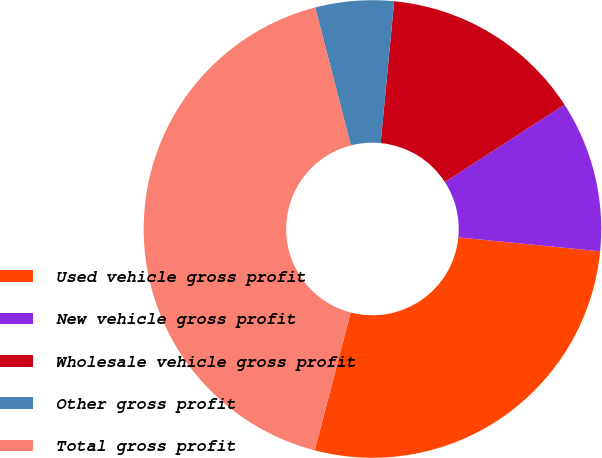Convert chart. <chart><loc_0><loc_0><loc_500><loc_500><pie_chart><fcel>Used vehicle gross profit<fcel>New vehicle gross profit<fcel>Wholesale vehicle gross profit<fcel>Other gross profit<fcel>Total gross profit<nl><fcel>27.51%<fcel>10.7%<fcel>14.34%<fcel>5.54%<fcel>41.91%<nl></chart> 